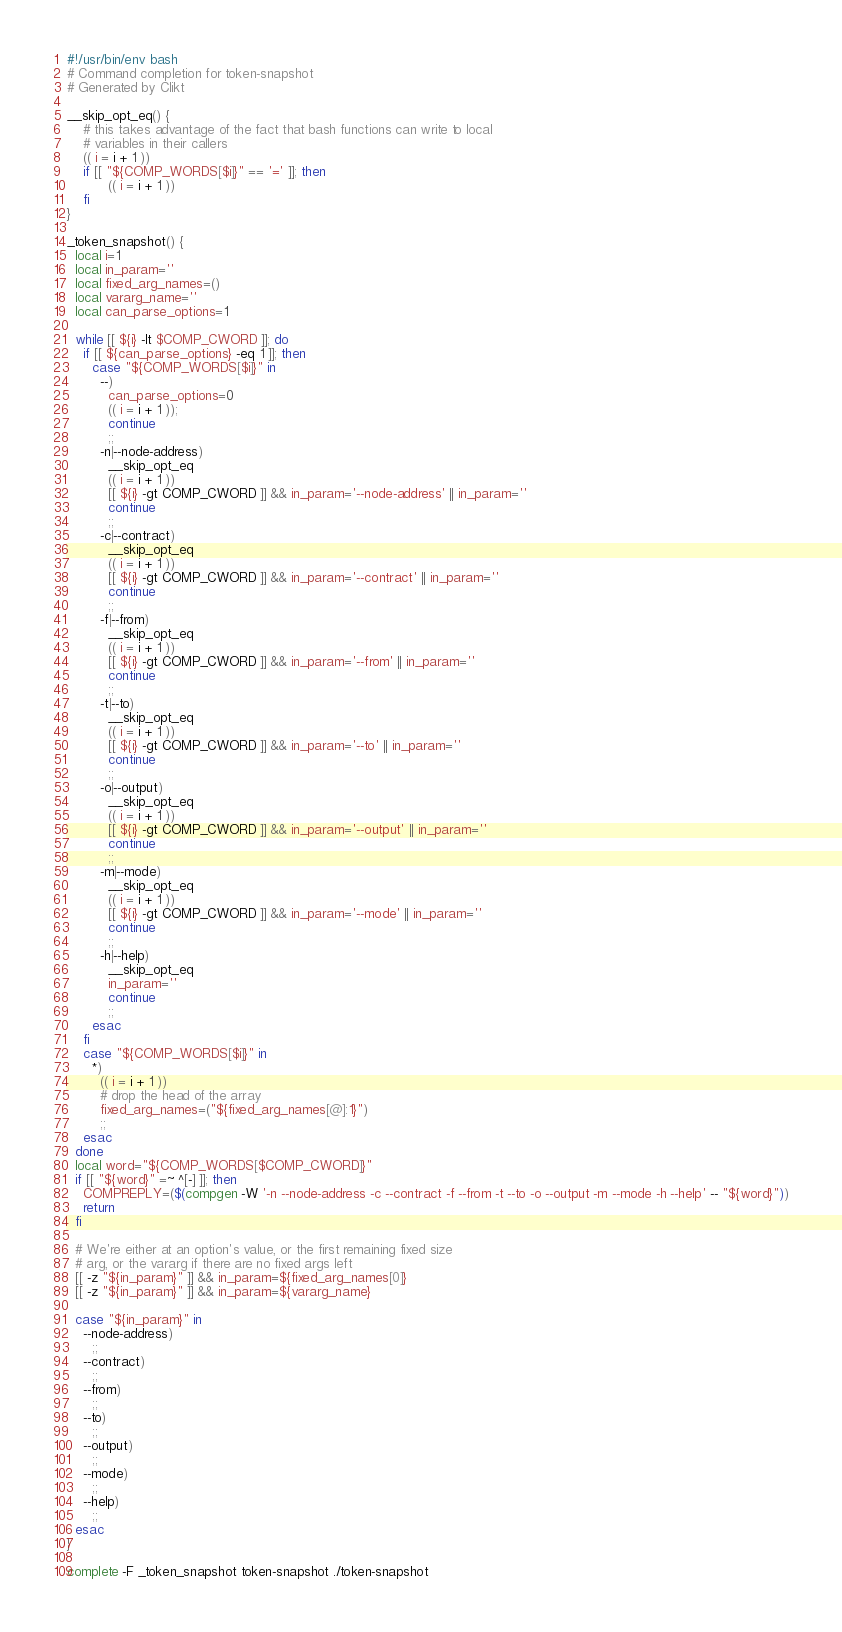<code> <loc_0><loc_0><loc_500><loc_500><_Bash_>#!/usr/bin/env bash
# Command completion for token-snapshot
# Generated by Clikt

__skip_opt_eq() {
    # this takes advantage of the fact that bash functions can write to local
    # variables in their callers
    (( i = i + 1 ))
    if [[ "${COMP_WORDS[$i]}" == '=' ]]; then
          (( i = i + 1 ))
    fi
}

_token_snapshot() {
  local i=1
  local in_param=''
  local fixed_arg_names=()
  local vararg_name=''
  local can_parse_options=1

  while [[ ${i} -lt $COMP_CWORD ]]; do
    if [[ ${can_parse_options} -eq 1 ]]; then
      case "${COMP_WORDS[$i]}" in
        --)
          can_parse_options=0
          (( i = i + 1 ));
          continue
          ;;
        -n|--node-address)
          __skip_opt_eq
          (( i = i + 1 ))
          [[ ${i} -gt COMP_CWORD ]] && in_param='--node-address' || in_param=''
          continue
          ;;
        -c|--contract)
          __skip_opt_eq
          (( i = i + 1 ))
          [[ ${i} -gt COMP_CWORD ]] && in_param='--contract' || in_param=''
          continue
          ;;
        -f|--from)
          __skip_opt_eq
          (( i = i + 1 ))
          [[ ${i} -gt COMP_CWORD ]] && in_param='--from' || in_param=''
          continue
          ;;
        -t|--to)
          __skip_opt_eq
          (( i = i + 1 ))
          [[ ${i} -gt COMP_CWORD ]] && in_param='--to' || in_param=''
          continue
          ;;
        -o|--output)
          __skip_opt_eq
          (( i = i + 1 ))
          [[ ${i} -gt COMP_CWORD ]] && in_param='--output' || in_param=''
          continue
          ;;
        -m|--mode)
          __skip_opt_eq
          (( i = i + 1 ))
          [[ ${i} -gt COMP_CWORD ]] && in_param='--mode' || in_param=''
          continue
          ;;
        -h|--help)
          __skip_opt_eq
          in_param=''
          continue
          ;;
      esac
    fi
    case "${COMP_WORDS[$i]}" in
      *)
        (( i = i + 1 ))
        # drop the head of the array
        fixed_arg_names=("${fixed_arg_names[@]:1}")
        ;;
    esac
  done
  local word="${COMP_WORDS[$COMP_CWORD]}"
  if [[ "${word}" =~ ^[-] ]]; then
    COMPREPLY=($(compgen -W '-n --node-address -c --contract -f --from -t --to -o --output -m --mode -h --help' -- "${word}"))
    return
  fi

  # We're either at an option's value, or the first remaining fixed size
  # arg, or the vararg if there are no fixed args left
  [[ -z "${in_param}" ]] && in_param=${fixed_arg_names[0]}
  [[ -z "${in_param}" ]] && in_param=${vararg_name}

  case "${in_param}" in
    --node-address)
      ;;
    --contract)
      ;;
    --from)
      ;;
    --to)
      ;;
    --output)
      ;;
    --mode)
      ;;
    --help)
      ;;
  esac
}

complete -F _token_snapshot token-snapshot ./token-snapshot
</code> 